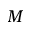Convert formula to latex. <formula><loc_0><loc_0><loc_500><loc_500>M</formula> 